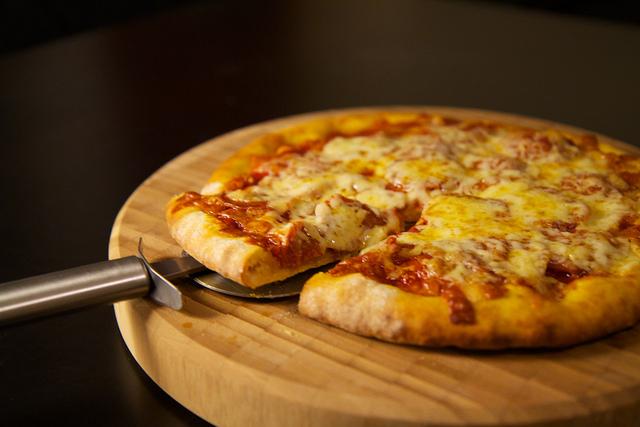What is under the slice?
Give a very brief answer. Pizza cutter. Is this Chinese food?
Give a very brief answer. No. What is that food?
Give a very brief answer. Pizza. 